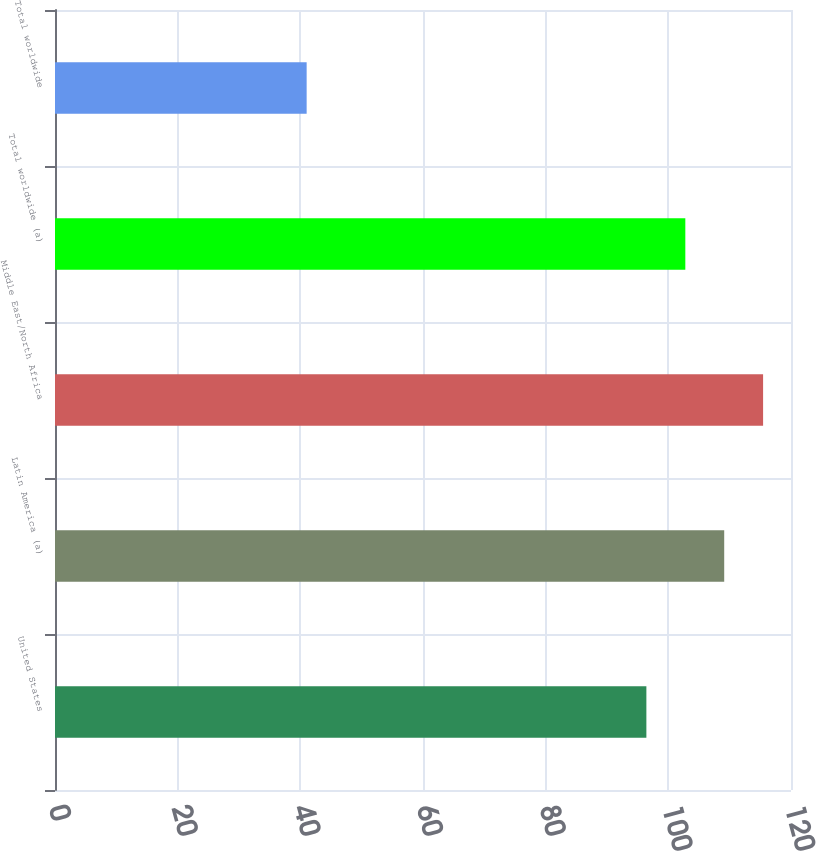Convert chart. <chart><loc_0><loc_0><loc_500><loc_500><bar_chart><fcel>United States<fcel>Latin America (a)<fcel>Middle East/North Africa<fcel>Total worldwide (a)<fcel>Total worldwide<nl><fcel>96.42<fcel>109.11<fcel>115.45<fcel>102.77<fcel>41.03<nl></chart> 